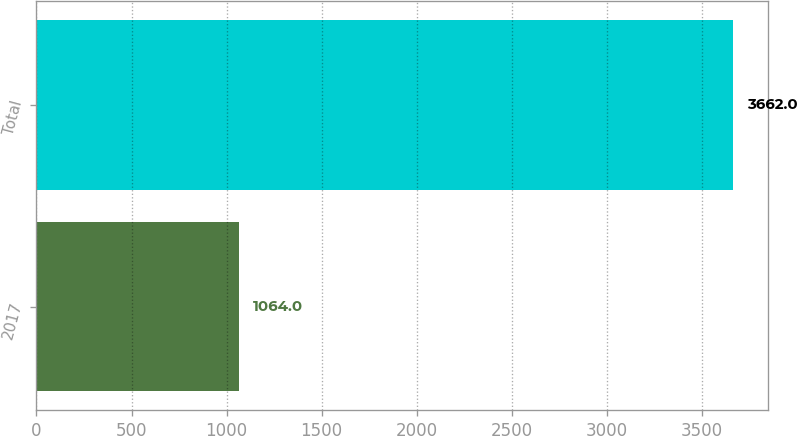Convert chart. <chart><loc_0><loc_0><loc_500><loc_500><bar_chart><fcel>2017<fcel>Total<nl><fcel>1064<fcel>3662<nl></chart> 